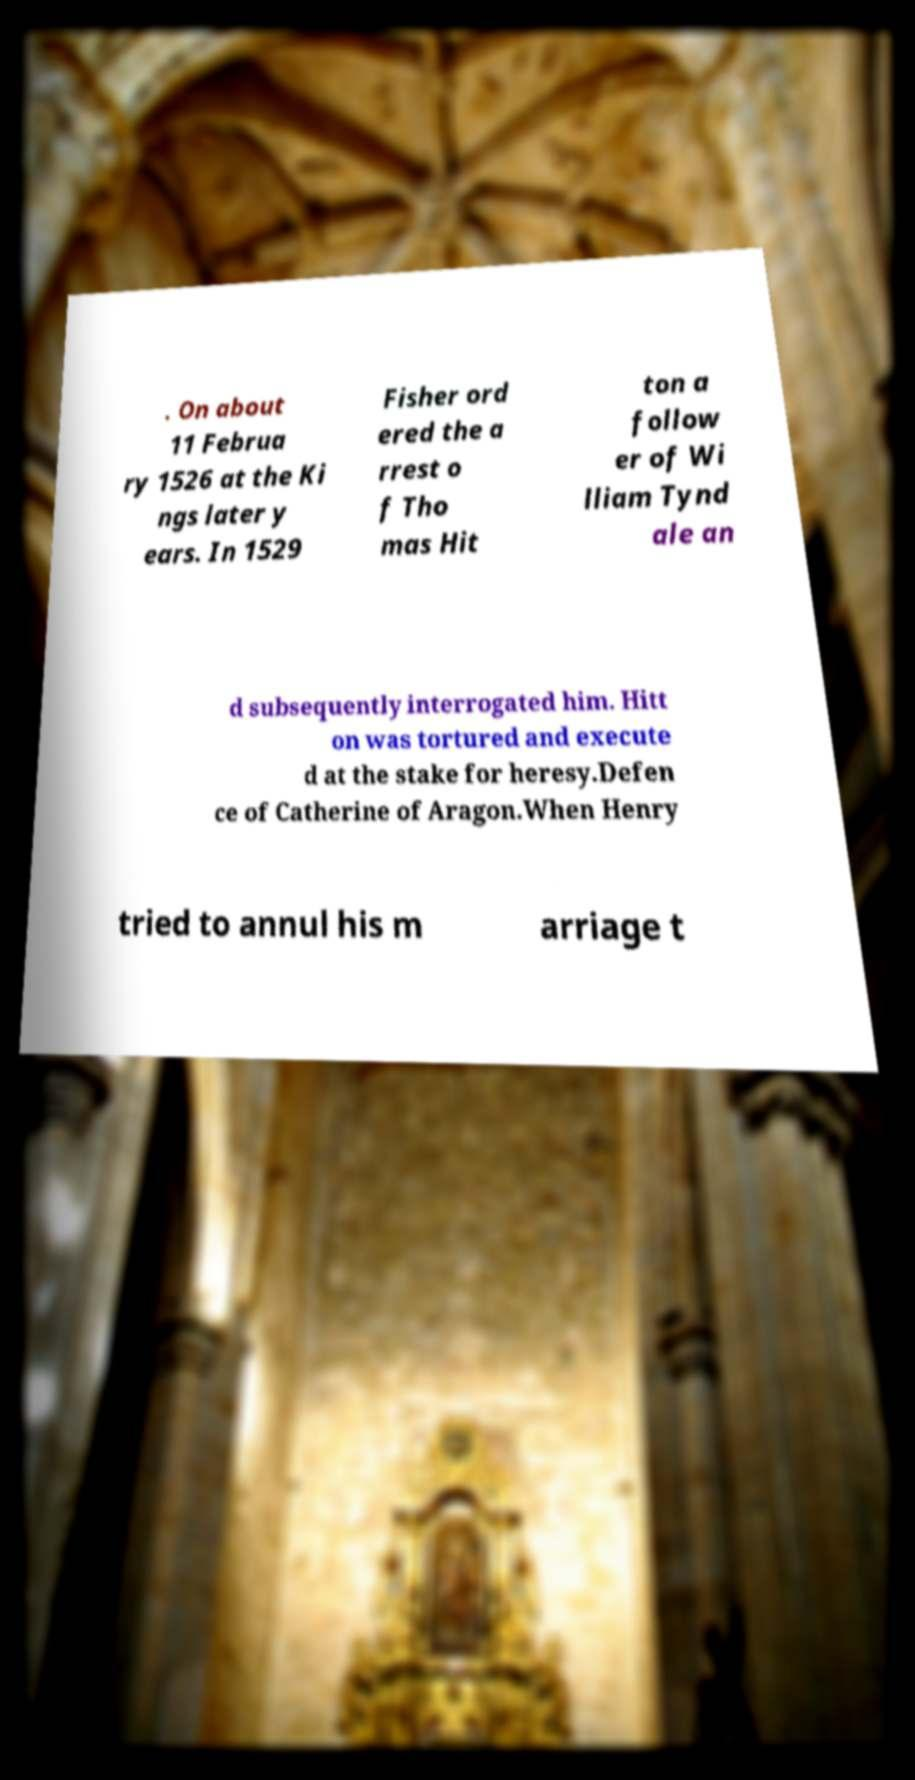What messages or text are displayed in this image? I need them in a readable, typed format. . On about 11 Februa ry 1526 at the Ki ngs later y ears. In 1529 Fisher ord ered the a rrest o f Tho mas Hit ton a follow er of Wi lliam Tynd ale an d subsequently interrogated him. Hitt on was tortured and execute d at the stake for heresy.Defen ce of Catherine of Aragon.When Henry tried to annul his m arriage t 